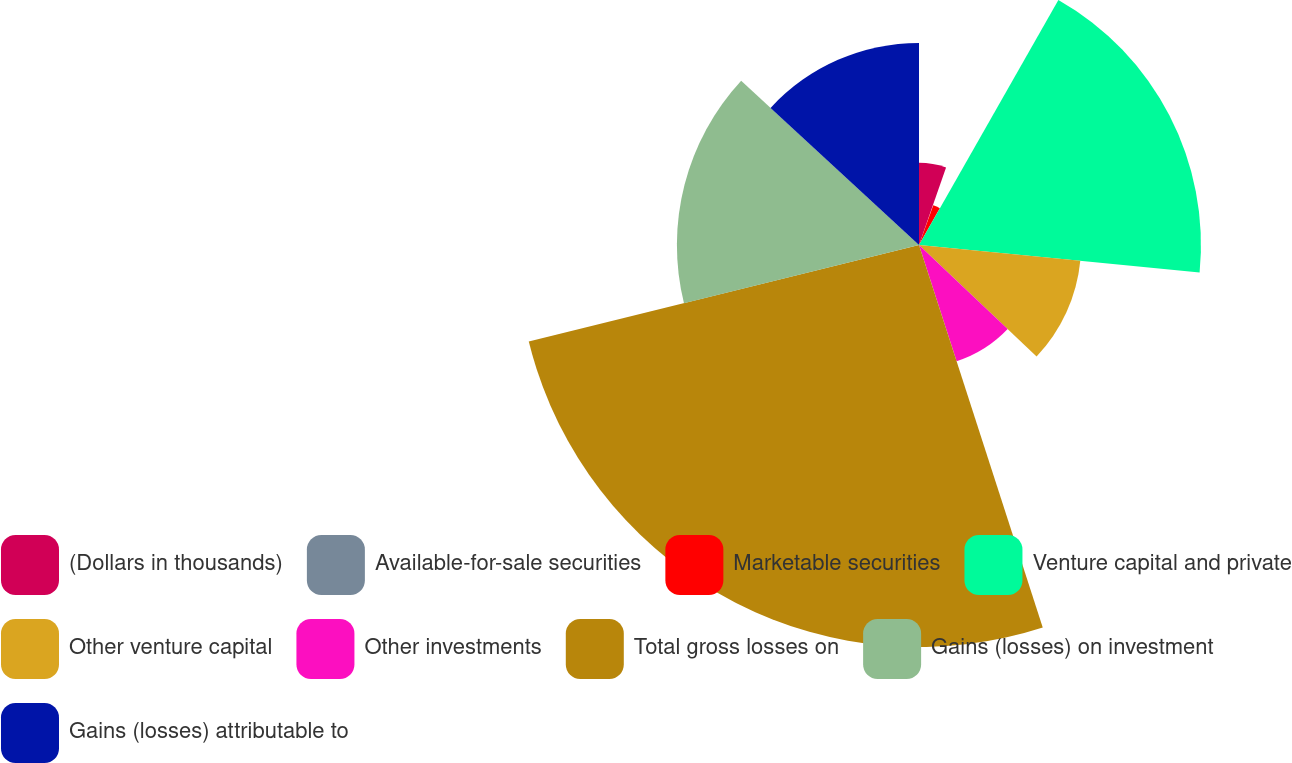<chart> <loc_0><loc_0><loc_500><loc_500><pie_chart><fcel>(Dollars in thousands)<fcel>Available-for-sale securities<fcel>Marketable securities<fcel>Venture capital and private<fcel>Other venture capital<fcel>Other investments<fcel>Total gross losses on<fcel>Gains (losses) on investment<fcel>Gains (losses) attributable to<nl><fcel>5.34%<fcel>0.15%<fcel>2.74%<fcel>18.32%<fcel>10.53%<fcel>7.94%<fcel>26.12%<fcel>15.73%<fcel>13.13%<nl></chart> 